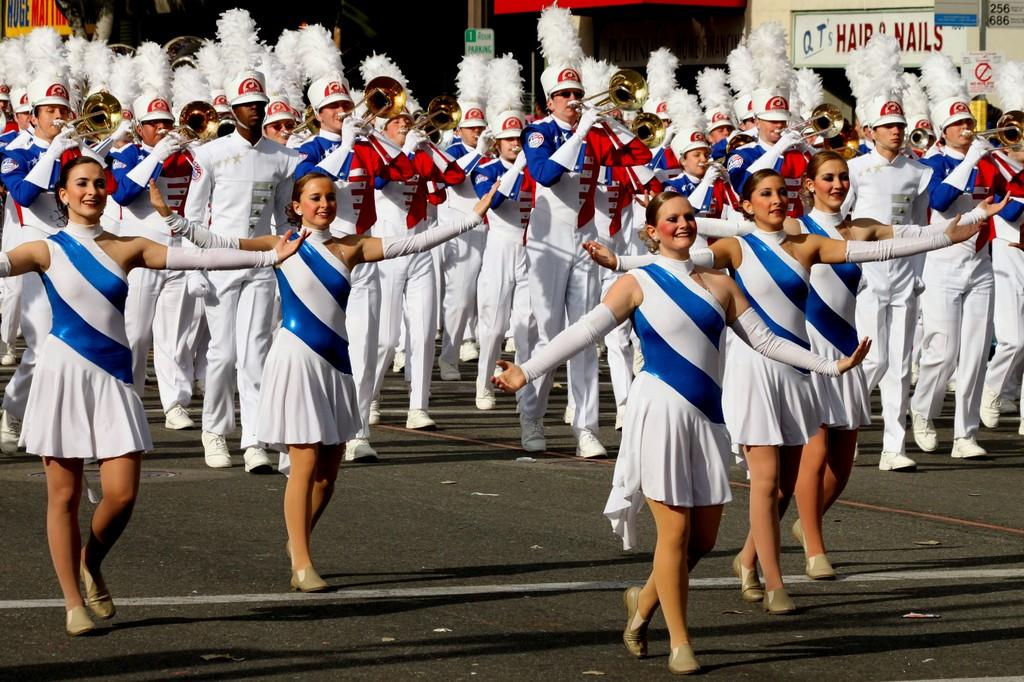<image>
Create a compact narrative representing the image presented. A sign for hair and nails can be seen in the background as a large marching bands performs on the street. 